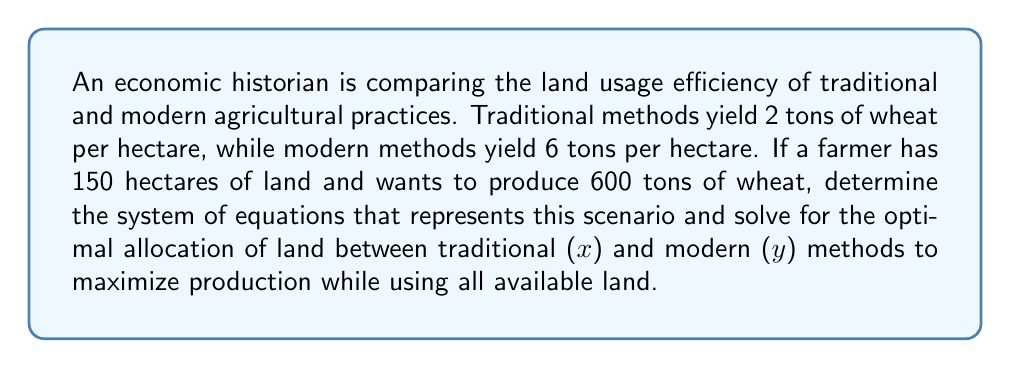Can you answer this question? 1. Set up the system of equations:
   - Land constraint: $x + y = 150$ (total available land)
   - Production goal: $2x + 6y = 600$ (total wheat production)

2. We now have a system of two equations with two unknowns:
   $$\begin{cases}
   x + y = 150 \\
   2x + 6y = 600
   \end{cases}$$

3. Solve the system using substitution method:
   From the first equation: $x = 150 - y$

4. Substitute this into the second equation:
   $2(150 - y) + 6y = 600$

5. Simplify:
   $300 - 2y + 6y = 600$
   $300 + 4y = 600$

6. Solve for y:
   $4y = 300$
   $y = 75$

7. Substitute y back into the equation from step 3 to find x:
   $x = 150 - 75 = 75$

8. Check the solution:
   $75 + 75 = 150$ (land constraint satisfied)
   $2(75) + 6(75) = 150 + 450 = 600$ (production goal met)

The optimal allocation is 75 hectares for traditional methods and 75 hectares for modern methods.
Answer: $x = 75, y = 75$ 